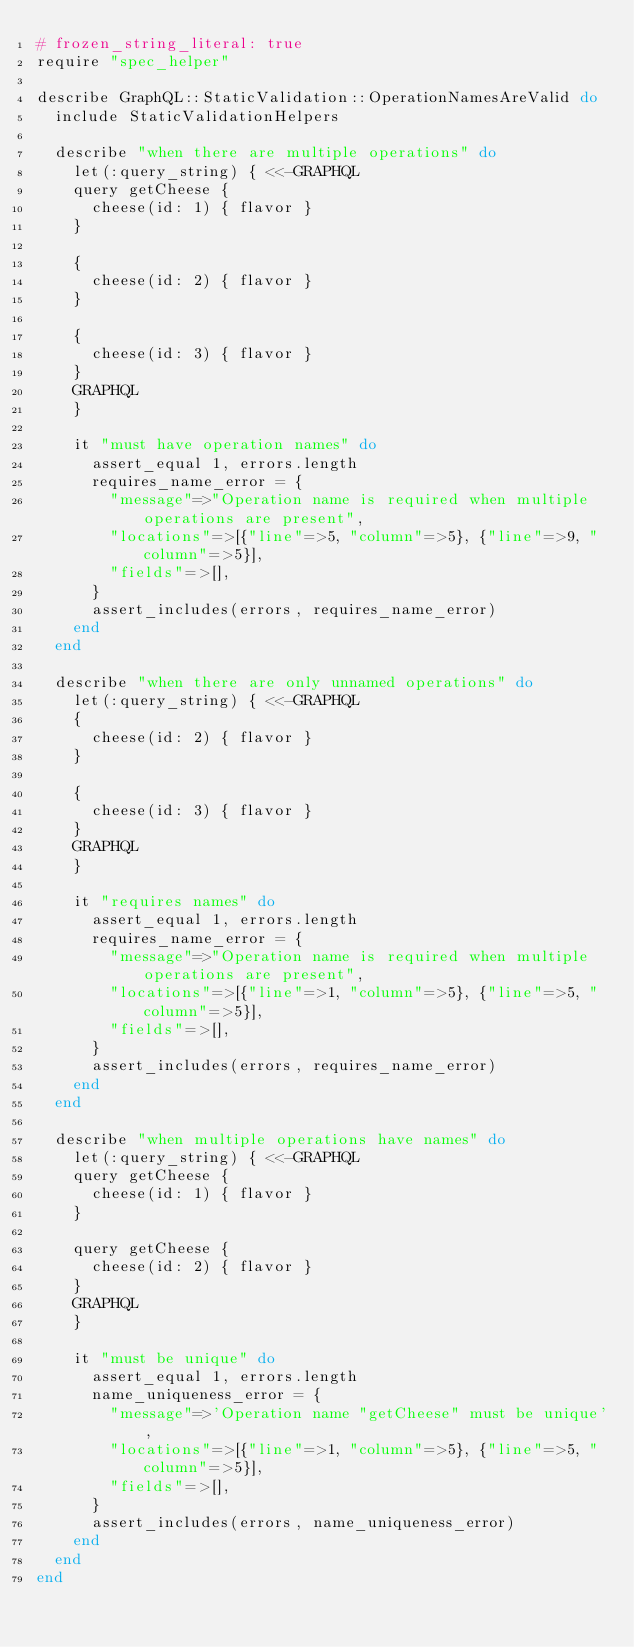<code> <loc_0><loc_0><loc_500><loc_500><_Ruby_># frozen_string_literal: true
require "spec_helper"

describe GraphQL::StaticValidation::OperationNamesAreValid do
  include StaticValidationHelpers

  describe "when there are multiple operations" do
    let(:query_string) { <<-GRAPHQL
    query getCheese {
      cheese(id: 1) { flavor }
    }

    {
      cheese(id: 2) { flavor }
    }

    {
      cheese(id: 3) { flavor }
    }
    GRAPHQL
    }

    it "must have operation names" do
      assert_equal 1, errors.length
      requires_name_error = {
        "message"=>"Operation name is required when multiple operations are present",
        "locations"=>[{"line"=>5, "column"=>5}, {"line"=>9, "column"=>5}],
        "fields"=>[],
      }
      assert_includes(errors, requires_name_error)
    end
  end

  describe "when there are only unnamed operations" do
    let(:query_string) { <<-GRAPHQL
    {
      cheese(id: 2) { flavor }
    }

    {
      cheese(id: 3) { flavor }
    }
    GRAPHQL
    }

    it "requires names" do
      assert_equal 1, errors.length
      requires_name_error = {
        "message"=>"Operation name is required when multiple operations are present",
        "locations"=>[{"line"=>1, "column"=>5}, {"line"=>5, "column"=>5}],
        "fields"=>[],
      }
      assert_includes(errors, requires_name_error)
    end
  end

  describe "when multiple operations have names" do
    let(:query_string) { <<-GRAPHQL
    query getCheese {
      cheese(id: 1) { flavor }
    }

    query getCheese {
      cheese(id: 2) { flavor }
    }
    GRAPHQL
    }

    it "must be unique" do
      assert_equal 1, errors.length
      name_uniqueness_error = {
        "message"=>'Operation name "getCheese" must be unique',
        "locations"=>[{"line"=>1, "column"=>5}, {"line"=>5, "column"=>5}],
        "fields"=>[],
      }
      assert_includes(errors, name_uniqueness_error)
    end
  end
end
</code> 